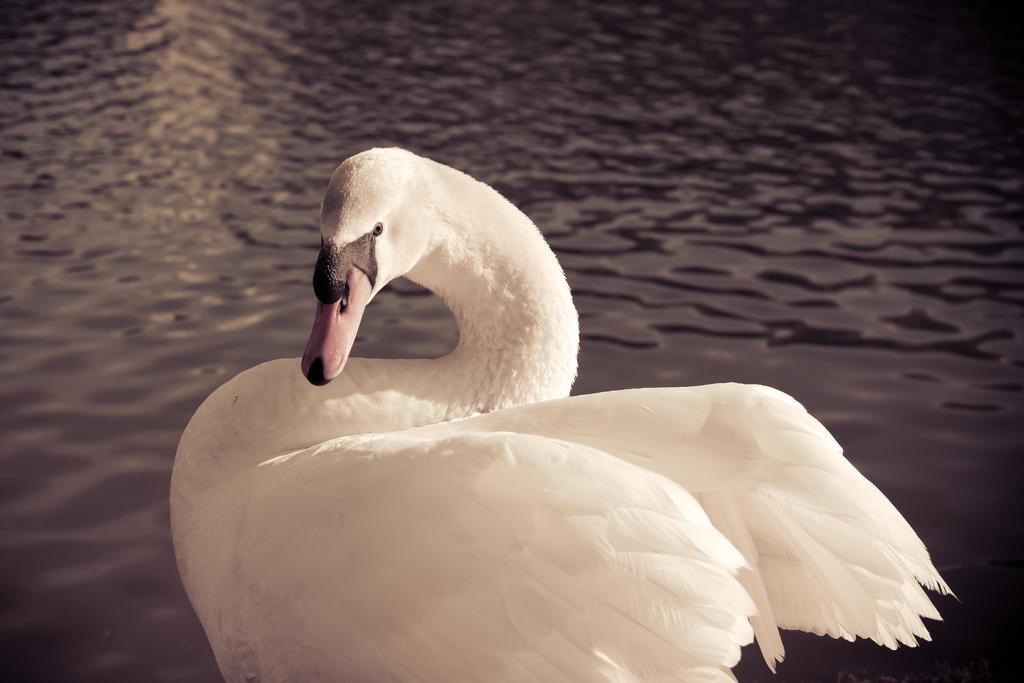Describe this image in one or two sentences. In this image we can see there is a dick. In the background there is a river. 